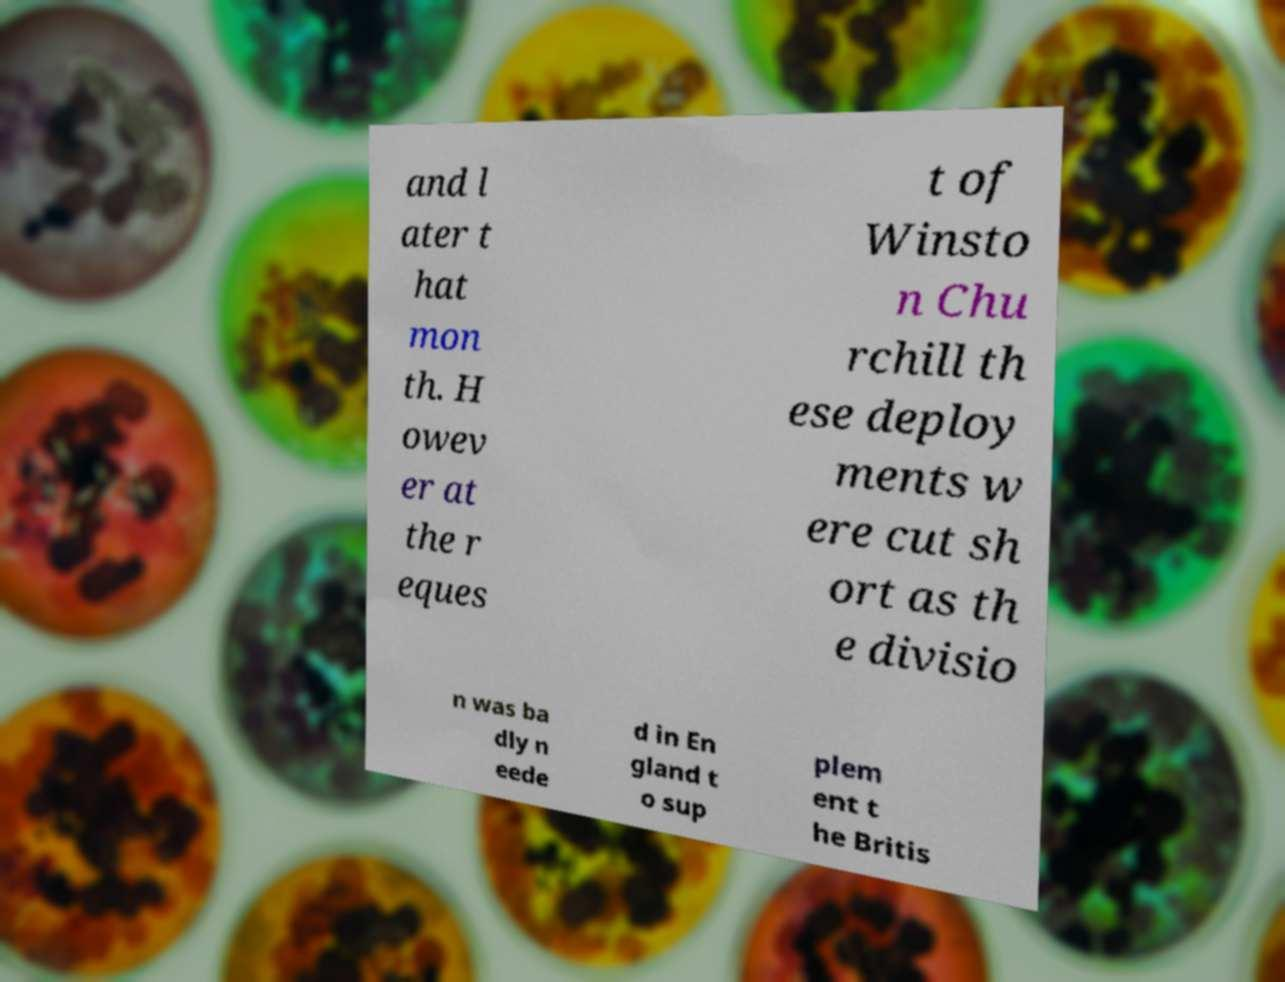Could you assist in decoding the text presented in this image and type it out clearly? and l ater t hat mon th. H owev er at the r eques t of Winsto n Chu rchill th ese deploy ments w ere cut sh ort as th e divisio n was ba dly n eede d in En gland t o sup plem ent t he Britis 